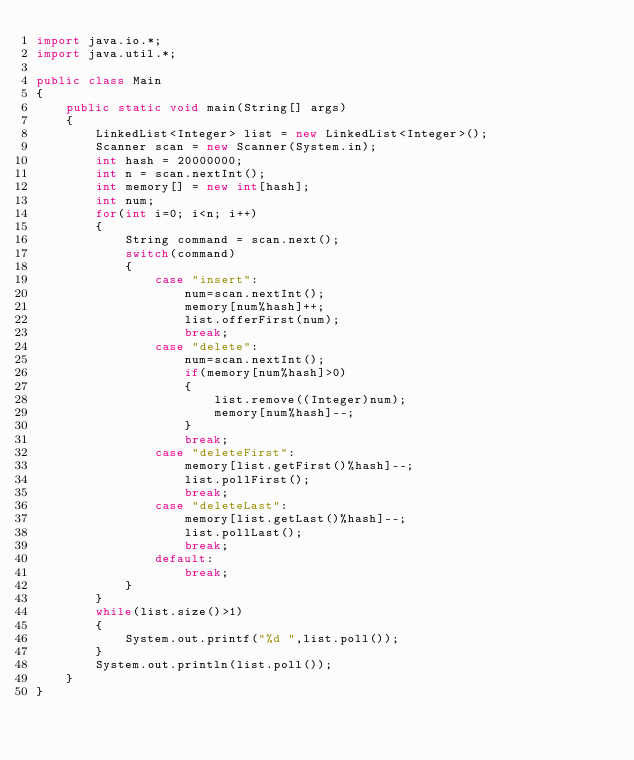<code> <loc_0><loc_0><loc_500><loc_500><_Java_>import java.io.*;
import java.util.*;

public class Main
{
    public static void main(String[] args)
    {
        LinkedList<Integer> list = new LinkedList<Integer>();
        Scanner scan = new Scanner(System.in);
        int hash = 20000000;
        int n = scan.nextInt();
        int memory[] = new int[hash];
        int num;
        for(int i=0; i<n; i++)
        {
            String command = scan.next();
            switch(command)
            {
                case "insert":
                    num=scan.nextInt();
                    memory[num%hash]++;
                    list.offerFirst(num);
                    break;
                case "delete":
                    num=scan.nextInt();
                    if(memory[num%hash]>0)
                    {
                        list.remove((Integer)num);
                        memory[num%hash]--;
                    }
                    break;
                case "deleteFirst":
                    memory[list.getFirst()%hash]--;
                    list.pollFirst();
                    break;
                case "deleteLast":
                    memory[list.getLast()%hash]--;
                    list.pollLast();
                    break;
                default:
                    break;
            }
        }
        while(list.size()>1)
        {
            System.out.printf("%d ",list.poll());
        }
        System.out.println(list.poll());
    }
}</code> 